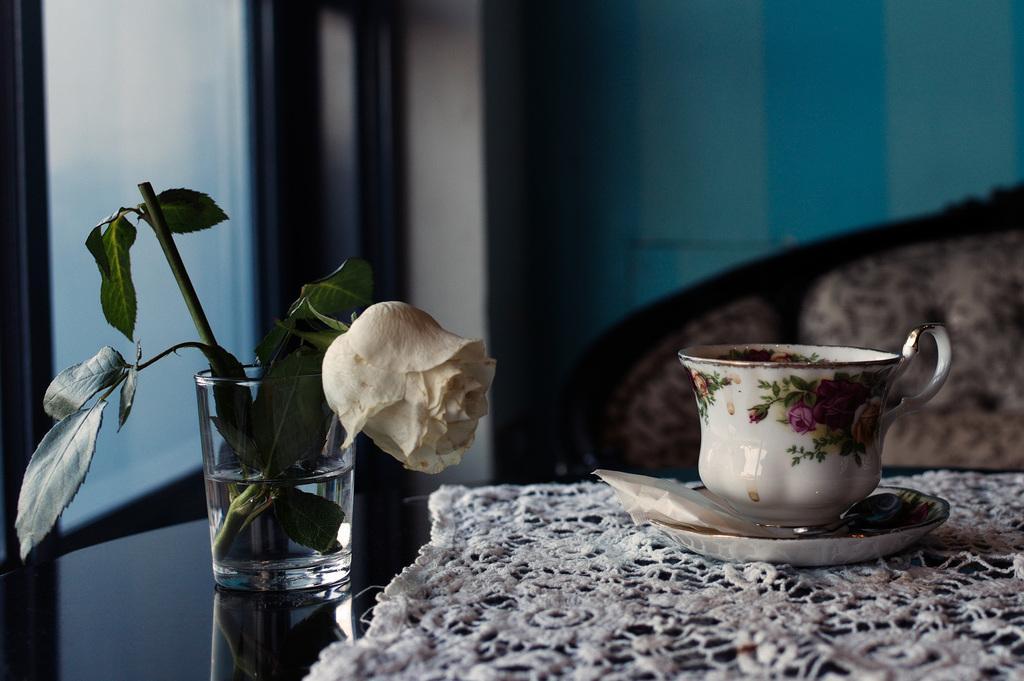In one or two sentences, can you explain what this image depicts? A glass of water with flower. On this table there is a cloth, saucer and cup. In-front of this table there is a couch. Beside this table there is a window. 